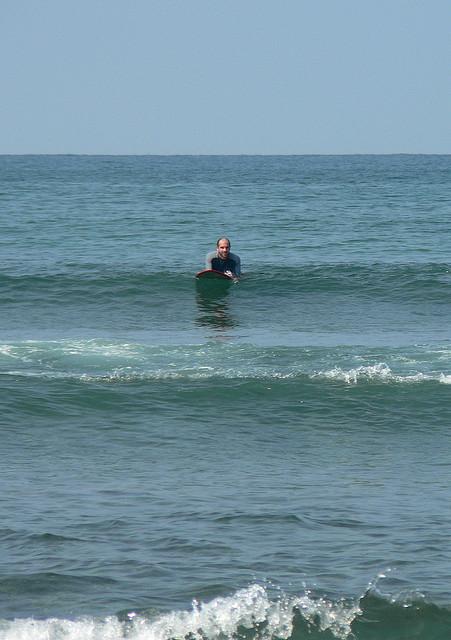Are there waves on the water?
Short answer required. Yes. What is the person doing?
Write a very short answer. Surfing. What color is his wetsuit?
Quick response, please. Blue. What is the person holding onto?
Be succinct. Surfboard. Is the water foamy?
Keep it brief. No. Why are the people lying on their boards instead of standing on them?
Answer briefly. Waiting for wave. How many people are in the water?
Be succinct. 1. Is the surfer paddling?
Quick response, please. Yes. What is the gender of this person?
Keep it brief. Male. Is this water wave heavy?
Concise answer only. No. Is the surfer "riding the wave" at this time?
Quick response, please. No. Is the water calm?
Answer briefly. Yes. What is the man doing?
Write a very short answer. Surfing. Is this man surfing through a curl?
Give a very brief answer. No. Is the surfer well balanced?
Concise answer only. Yes. Is he standing on the board?
Give a very brief answer. No. How deep is the water?
Short answer required. Very deep. 